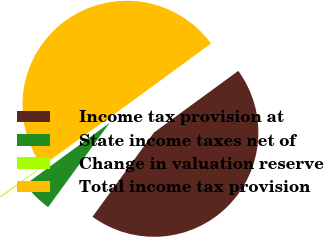Convert chart to OTSL. <chart><loc_0><loc_0><loc_500><loc_500><pie_chart><fcel>Income tax provision at<fcel>State income taxes net of<fcel>Change in valuation reserve<fcel>Total income tax provision<nl><fcel>45.08%<fcel>4.92%<fcel>0.17%<fcel>49.83%<nl></chart> 